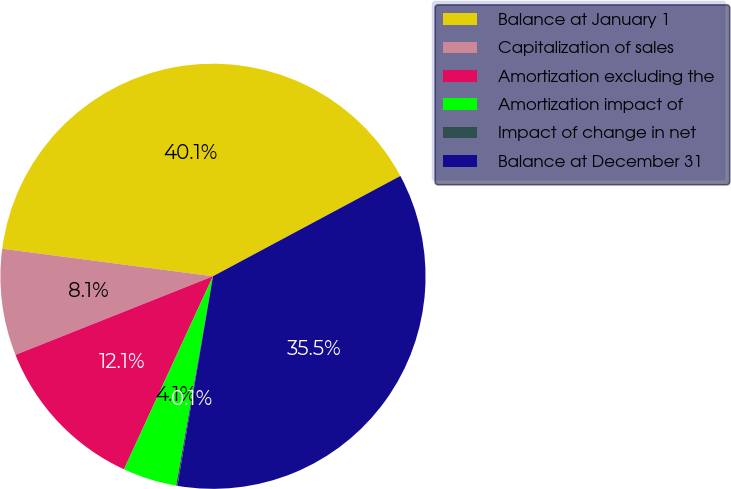Convert chart to OTSL. <chart><loc_0><loc_0><loc_500><loc_500><pie_chart><fcel>Balance at January 1<fcel>Capitalization of sales<fcel>Amortization excluding the<fcel>Amortization impact of<fcel>Impact of change in net<fcel>Balance at December 31<nl><fcel>40.11%<fcel>8.1%<fcel>12.1%<fcel>4.1%<fcel>0.1%<fcel>35.5%<nl></chart> 